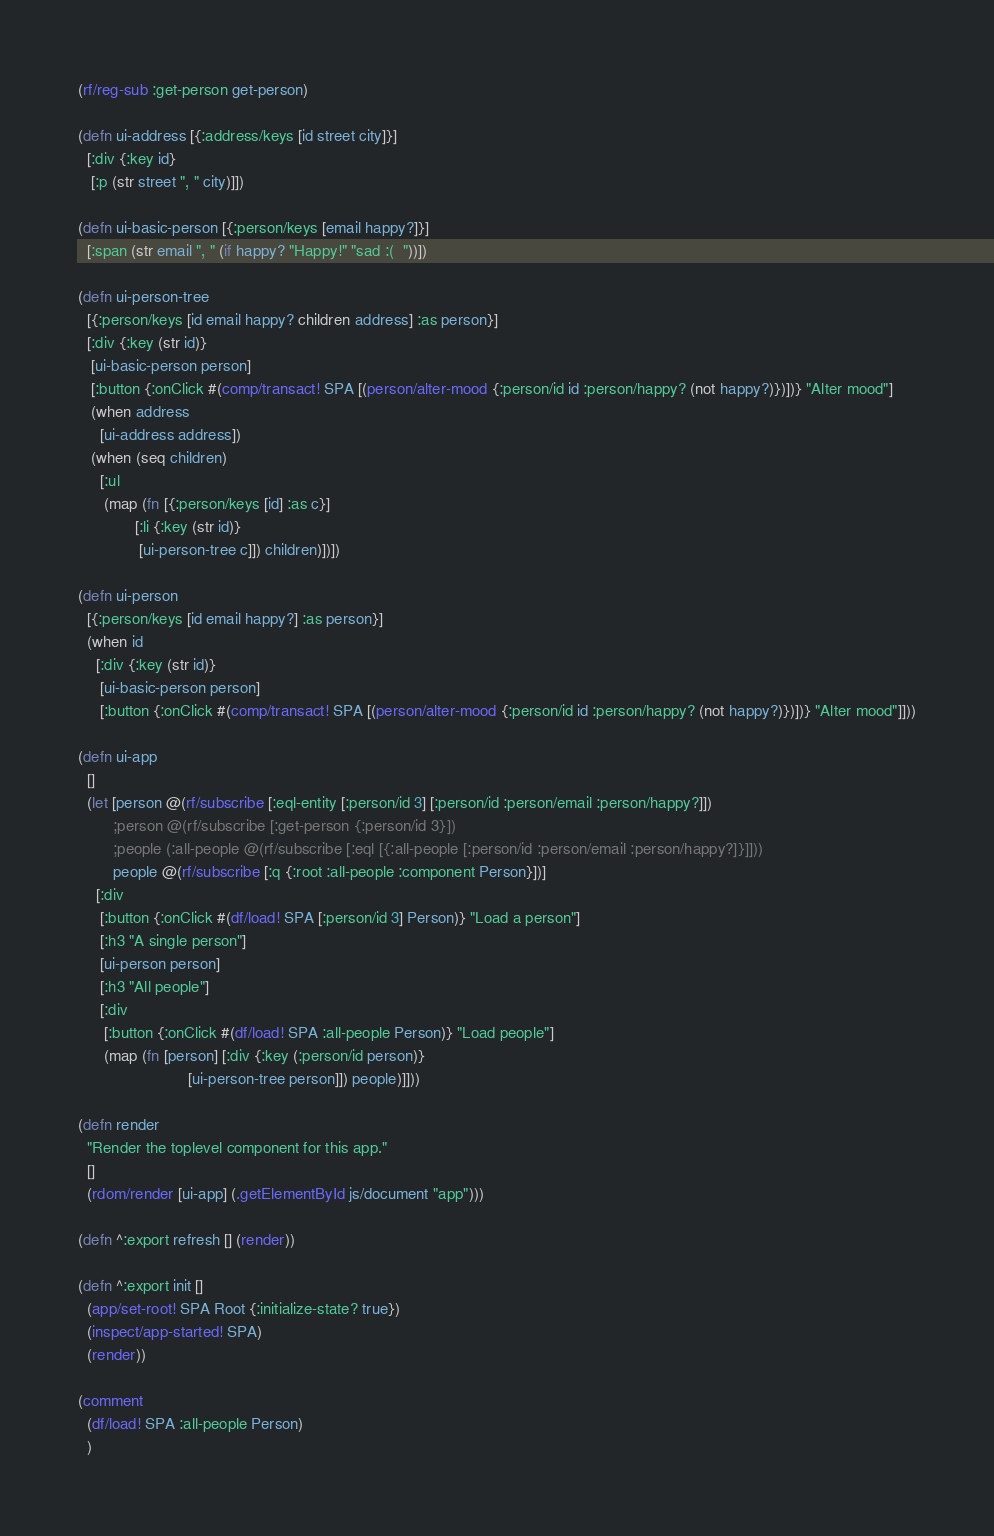Convert code to text. <code><loc_0><loc_0><loc_500><loc_500><_Clojure_>(rf/reg-sub :get-person get-person)

(defn ui-address [{:address/keys [id street city]}]
  [:div {:key id}
   [:p (str street ", " city)]])

(defn ui-basic-person [{:person/keys [email happy?]}]
  [:span (str email ", " (if happy? "Happy!" "sad :(  "))])

(defn ui-person-tree
  [{:person/keys [id email happy? children address] :as person}]
  [:div {:key (str id)}
   [ui-basic-person person]
   [:button {:onClick #(comp/transact! SPA [(person/alter-mood {:person/id id :person/happy? (not happy?)})])} "Alter mood"]
   (when address
     [ui-address address])
   (when (seq children)
     [:ul
      (map (fn [{:person/keys [id] :as c}]
             [:li {:key (str id)}
              [ui-person-tree c]]) children)])])

(defn ui-person
  [{:person/keys [id email happy?] :as person}]
  (when id
    [:div {:key (str id)}
     [ui-basic-person person]
     [:button {:onClick #(comp/transact! SPA [(person/alter-mood {:person/id id :person/happy? (not happy?)})])} "Alter mood"]]))

(defn ui-app
  []
  (let [person @(rf/subscribe [:eql-entity [:person/id 3] [:person/id :person/email :person/happy?]])
        ;person @(rf/subscribe [:get-person {:person/id 3}])
        ;people (:all-people @(rf/subscribe [:eql [{:all-people [:person/id :person/email :person/happy?]}]]))
        people @(rf/subscribe [:q {:root :all-people :component Person}])]
    [:div
     [:button {:onClick #(df/load! SPA [:person/id 3] Person)} "Load a person"]
     [:h3 "A single person"]
     [ui-person person]
     [:h3 "All people"]
     [:div
      [:button {:onClick #(df/load! SPA :all-people Person)} "Load people"]
      (map (fn [person] [:div {:key (:person/id person)}
                         [ui-person-tree person]]) people)]]))

(defn render
  "Render the toplevel component for this app."
  []
  (rdom/render [ui-app] (.getElementById js/document "app")))

(defn ^:export refresh [] (render))

(defn ^:export init []
  (app/set-root! SPA Root {:initialize-state? true})
  (inspect/app-started! SPA)
  (render))

(comment
  (df/load! SPA :all-people Person)
  )
</code> 